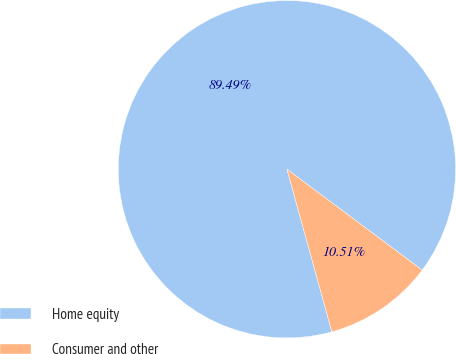Convert chart to OTSL. <chart><loc_0><loc_0><loc_500><loc_500><pie_chart><fcel>Home equity<fcel>Consumer and other<nl><fcel>89.49%<fcel>10.51%<nl></chart> 